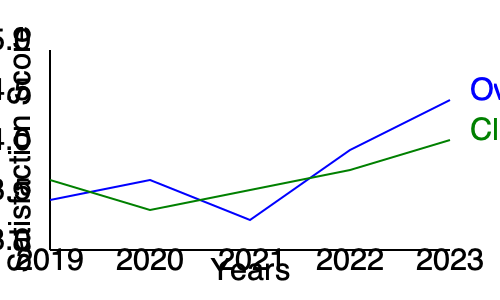As a B&B owner, you've been tracking guest satisfaction scores over the past five years. The graph shows two trends: overall satisfaction (blue) and cleanliness satisfaction (green). What conclusion can you draw about the relationship between overall satisfaction and cleanliness satisfaction, and what might be a potential area for improvement? To answer this question, let's analyze the graph step by step:

1. Overall satisfaction trend (blue line):
   - Starts at around 3.5 in 2019
   - Dips slightly in 2020
   - Rises in 2021
   - Shows a significant increase from 2021 to 2023, reaching about 4.5

2. Cleanliness satisfaction trend (green line):
   - Starts at about 3.7 in 2019
   - Increases in 2020
   - Decreases in 2021
   - Shows a gradual increase from 2021 to 2023, reaching about 4.1

3. Relationship between overall and cleanliness satisfaction:
   - The two lines show different patterns, indicating that overall satisfaction is not solely dependent on cleanliness.
   - Overall satisfaction has improved more dramatically than cleanliness satisfaction.

4. Potential area for improvement:
   - While both scores have improved, the cleanliness satisfaction score (4.1) is lower than the overall satisfaction score (4.5) in 2023.
   - This suggests that cleanliness could be an area for improvement to bring it in line with the overall satisfaction level.

Conclusion: The overall satisfaction has improved more significantly than cleanliness satisfaction. While both have positive trends, cleanliness scores lag behind overall satisfaction, indicating a potential area for improvement.
Answer: Cleanliness satisfaction lags behind overall satisfaction, presenting an opportunity for improvement. 